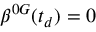<formula> <loc_0><loc_0><loc_500><loc_500>\beta ^ { 0 G } ( t _ { d } ) = 0</formula> 